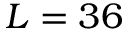<formula> <loc_0><loc_0><loc_500><loc_500>L = 3 6</formula> 